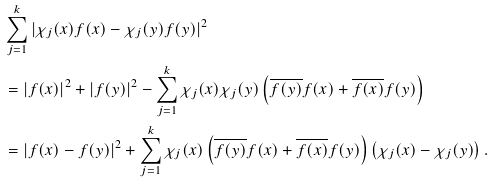Convert formula to latex. <formula><loc_0><loc_0><loc_500><loc_500>& \sum _ { j = 1 } ^ { k } | \chi _ { j } ( x ) f ( x ) - \chi _ { j } ( y ) f ( y ) | ^ { 2 } \\ & = | f ( x ) | ^ { 2 } + | f ( y ) | ^ { 2 } - \sum _ { j = 1 } ^ { k } \chi _ { j } ( x ) \chi _ { j } ( y ) \left ( \overline { f ( y ) } f ( x ) + \overline { f ( x ) } f ( y ) \right ) \\ & = | f ( x ) - f ( y ) | ^ { 2 } + \sum _ { j = 1 } ^ { k } \chi _ { j } ( x ) \left ( \overline { f ( y ) } f ( x ) + \overline { f ( x ) } f ( y ) \right ) \left ( \chi _ { j } ( x ) - \chi _ { j } ( y ) \right ) .</formula> 